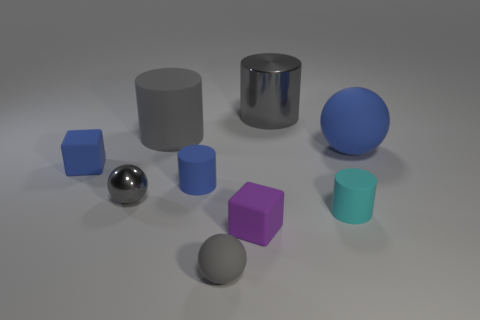There is another sphere that is the same color as the tiny rubber sphere; what is its material?
Ensure brevity in your answer.  Metal. How big is the gray ball right of the tiny cylinder that is on the left side of the small cyan rubber cylinder?
Offer a very short reply. Small. Is the number of balls greater than the number of shiny things?
Your answer should be compact. Yes. Do the matte cylinder that is behind the big blue thing and the matte ball that is on the left side of the large blue matte thing have the same color?
Offer a terse response. Yes. There is a block that is to the left of the small purple object; are there any large things on the right side of it?
Provide a short and direct response. Yes. Is the number of large gray cylinders that are on the left side of the small blue block less than the number of tiny purple blocks that are in front of the small gray rubber thing?
Offer a terse response. No. Is the blue thing in front of the blue cube made of the same material as the tiny object to the right of the metal cylinder?
Give a very brief answer. Yes. What number of big objects are cylinders or yellow matte spheres?
Ensure brevity in your answer.  2. The tiny gray object that is the same material as the tiny cyan object is what shape?
Offer a very short reply. Sphere. Is the number of gray balls behind the small gray rubber ball less than the number of big blue metallic balls?
Keep it short and to the point. No. 